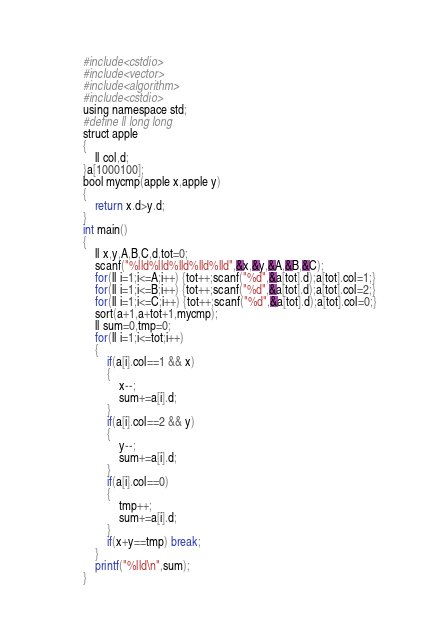<code> <loc_0><loc_0><loc_500><loc_500><_Awk_>#include<cstdio>
#include<vector>
#include<algorithm>
#include<cstdio>
using namespace std;
#define ll long long
struct apple
{
    ll col,d;
}a[1000100];
bool mycmp(apple x,apple y)
{
    return x.d>y.d;
}
int main()
{
    ll x,y,A,B,C,d,tot=0;
    scanf("%lld%lld%lld%lld%lld",&x,&y,&A,&B,&C);
    for(ll i=1;i<=A;i++) {tot++;scanf("%d",&a[tot].d);a[tot].col=1;}
    for(ll i=1;i<=B;i++) {tot++;scanf("%d",&a[tot].d);a[tot].col=2;}
    for(ll i=1;i<=C;i++) {tot++;scanf("%d",&a[tot].d);a[tot].col=0;}
    sort(a+1,a+tot+1,mycmp);
    ll sum=0,tmp=0;
    for(ll i=1;i<=tot;i++)
    {
        if(a[i].col==1 && x)
        {
            x--;
            sum+=a[i].d;
        }
        if(a[i].col==2 && y)
        {
            y--;
            sum+=a[i].d;
        }
        if(a[i].col==0)
        {
            tmp++;
            sum+=a[i].d;
        }
        if(x+y==tmp) break;
    }
    printf("%lld\n",sum);
}
</code> 